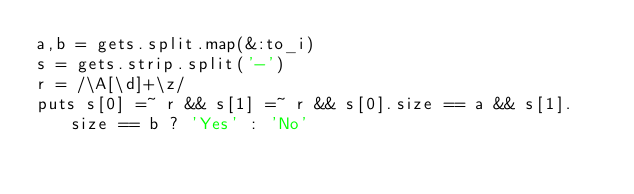<code> <loc_0><loc_0><loc_500><loc_500><_Ruby_>a,b = gets.split.map(&:to_i)
s = gets.strip.split('-')
r = /\A[\d]+\z/
puts s[0] =~ r && s[1] =~ r && s[0].size == a && s[1].size == b ? 'Yes' : 'No'

</code> 